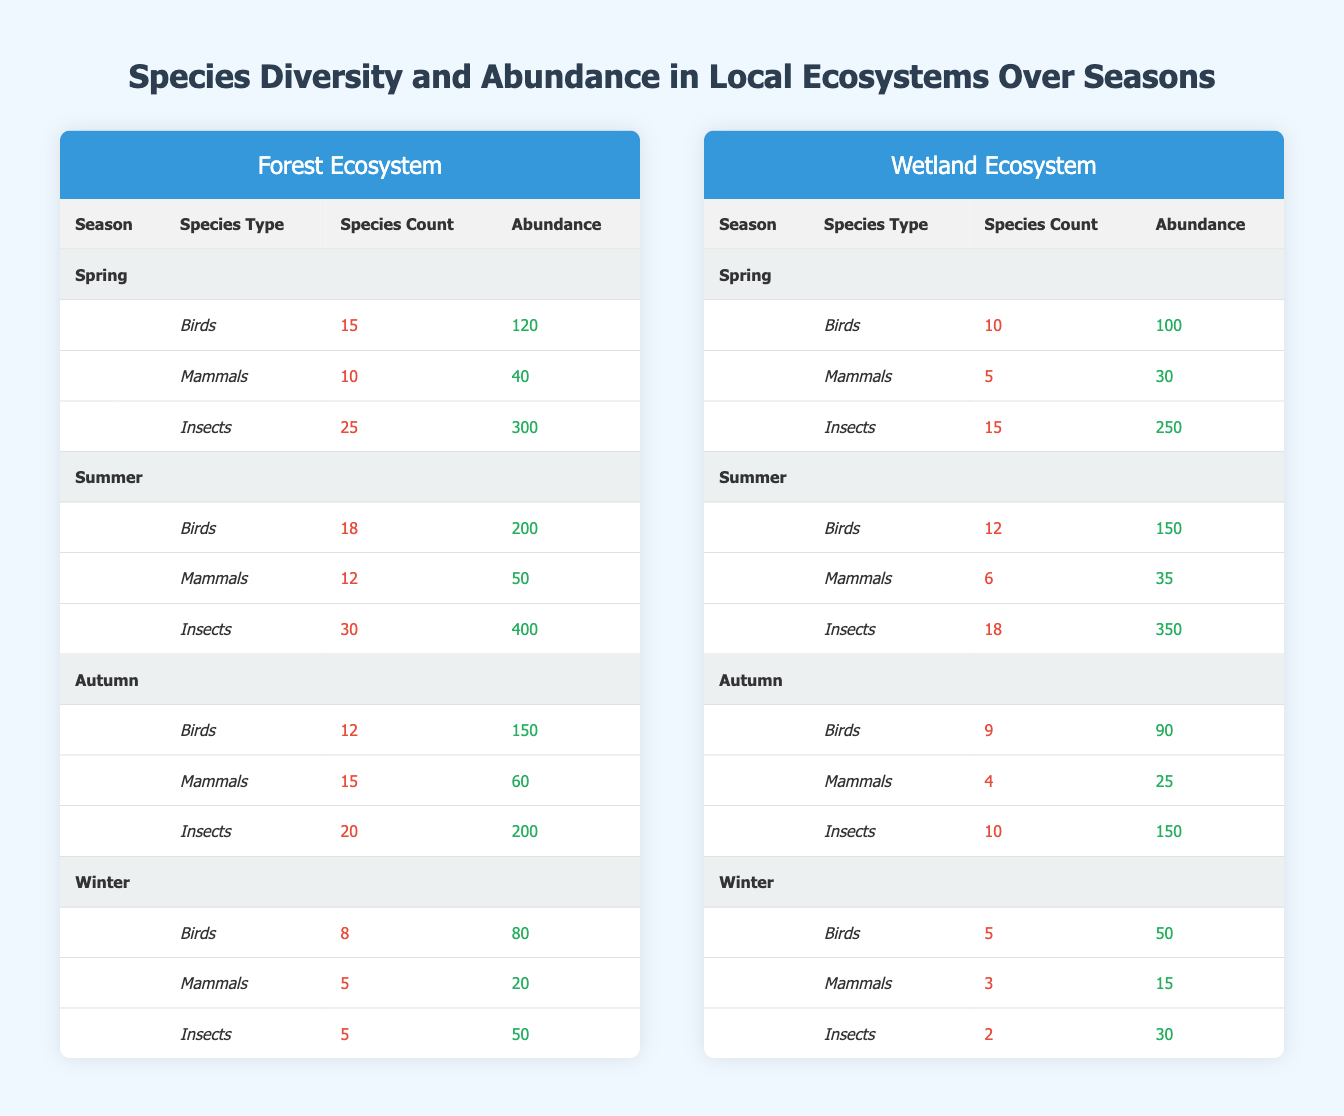What is the total number of bird species recorded in the Forest during Autumn? In Autumn, the table shows that there are 12 bird species in the Forest ecosystem. Thus, the total number of bird species in Autumn is 12.
Answer: 12 What is the average abundance of mammals in the Wetland ecosystem across all seasons? To find the average abundance of mammals in the Wetland, we sum the abundances across all seasons: Spring (30) + Summer (35) + Autumn (25) + Winter (15) = 105. We divide by the number of seasons, so 105/4 = 26.25.
Answer: 26.25 Is there a higher abundance of insects in Summer compared to Winter in the Forest ecosystem? The abundance of insects in the Forest during Summer is 400, while in Winter it is 50. Since 400 is greater than 50, the statement is true.
Answer: Yes How many species of mammals are present in the Wetland ecosystem during Winter? The table indicates that in Winter, there are 3 species of mammals in the Wetland ecosystem.
Answer: 3 What is the total insect abundance in the Forest ecosystem during Spring and Autumn combined? In Spring, the insect abundance is 300, and in Autumn, it is 200. Adding these together gives us 300 + 200 = 500.
Answer: 500 What is the difference in species count of birds between Summer and Winter in the Wetland? In Summer, there are 12 bird species, whereas in Winter, there are 5. The difference is 12 - 5 = 7.
Answer: 7 Does the Forest ecosystem have more species of insects than mammals in Spring? In Spring, the Forest shows 25 species of insects and 10 species of mammals. Since 25 is greater than 10, the statement is true.
Answer: Yes Which season has the highest total species count in the Forest and what is that count? In Summer, the species counts are: Birds (18) + Mammals (12) + Insects (30) = 60 total species. Other seasons have lower totals when calculated (Spring: 50, Autumn: 47, Winter: 18). Therefore, Summer has the highest total species count of 60.
Answer: 60 